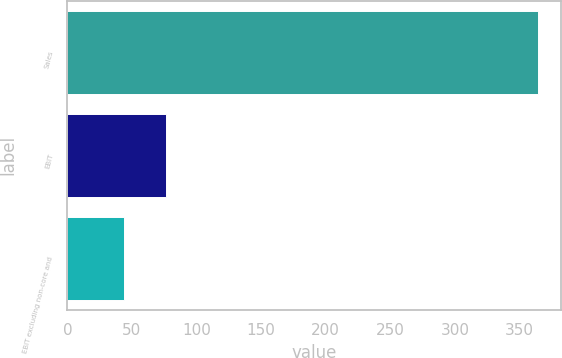Convert chart. <chart><loc_0><loc_0><loc_500><loc_500><bar_chart><fcel>Sales<fcel>EBIT<fcel>EBIT excluding non-core and<nl><fcel>364<fcel>76<fcel>44<nl></chart> 